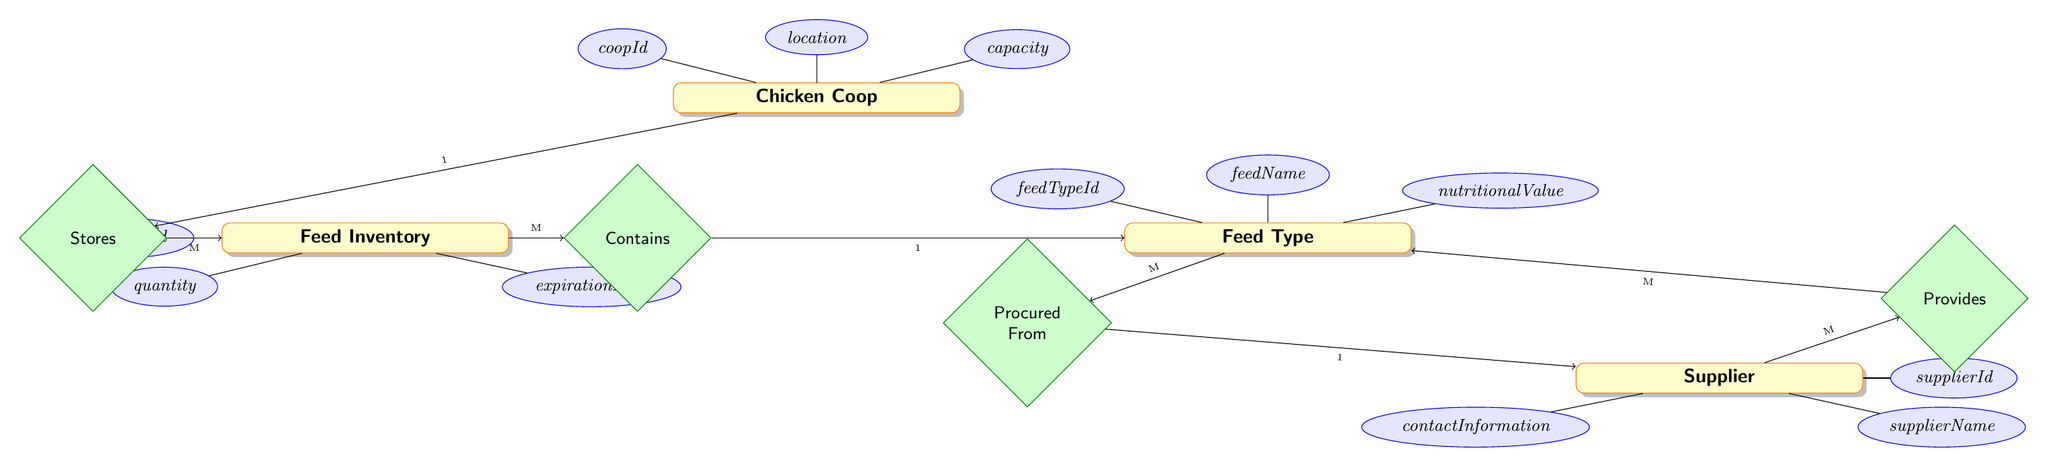What's the primary relationship between Chicken Coop and Feed Inventory? The diagram clearly shows a one-to-many relationship between Chicken Coop and Feed Inventory, indicating that a single chicken coop can store multiple feed inventories.
Answer: one-to-many How many attributes does the Feed Type entity have? The Feed Type entity contains three attributes listed in the diagram: feedTypeId, feedName, and nutritionalValue.
Answer: three What is the maximum number of Feed Types provided by a single Supplier? The diagram indicates a many-to-many relationship between Supplier and Feed Type, meaning a single supplier can provide multiple types of feed.
Answer: multiple Which entity has the attribute 'expirationDate'? Looking at the diagram, the attribute 'expirationDate' is connected only to the Feed Inventory entity.
Answer: Feed Inventory What type of relationship exists between Feed Inventory and Feed Type? The relationship is indicated as many-to-one, meaning multiple feed inventories can contain the same feed type.
Answer: many-to-one How many entities are shown in the diagram? Counting the entities displayed (Chicken Coop, Feed Type, Feed Inventory, and Supplier), there are four distinct entities present.
Answer: four What does the relationship labeled 'Procured From' indicate? This relationship is many-to-one, showing that multiple feed types can be procured from a single supplier, highlighting supplier relationships.
Answer: many-to-one Does a Chicken Coop have a direct relationship with the Supplier entity? Upon examining the relationships in the diagram, Chicken Coop does not have a direct relationship with the Supplier; it connects through Feed Inventory and Feed Type.
Answer: no Which attribute describes the location of the Chicken Coop? The attribute connected to the Chicken Coop entity regarding its location is simply named 'location.'
Answer: location 